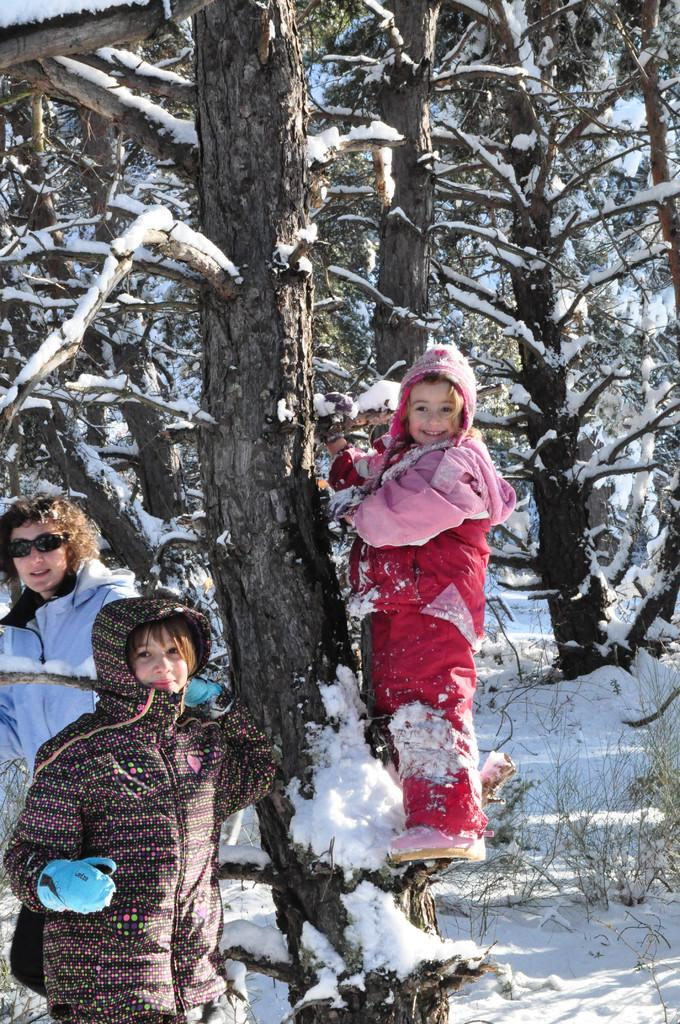How many people are in the image? There are three persons standing in the image. What is the person in front wearing? The person in front is wearing a pink jacket. What can be seen in the background of the image? There are trees in the background of the image. What is the condition of the trees in the image? The trees are covered with snow. What is the color of the snow in the image? The snow is white in color. What type of blade is the person in the middle holding in the image? There is no blade present in the image; the three persons are not holding any objects. What does the mom in the image feel about the snow? There is no mention of a mom or any feelings in the image; it only shows three persons and trees covered in snow. 